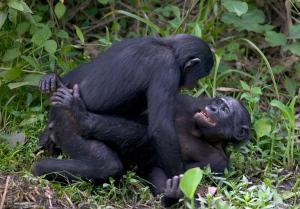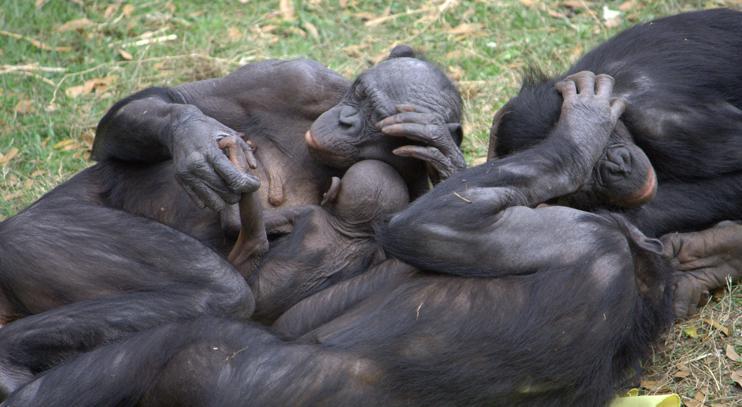The first image is the image on the left, the second image is the image on the right. Assess this claim about the two images: "there is a mother chimp holding her infant". Correct or not? Answer yes or no. Yes. The first image is the image on the left, the second image is the image on the right. Given the left and right images, does the statement "At least one of the monkeys is a baby." hold true? Answer yes or no. Yes. 